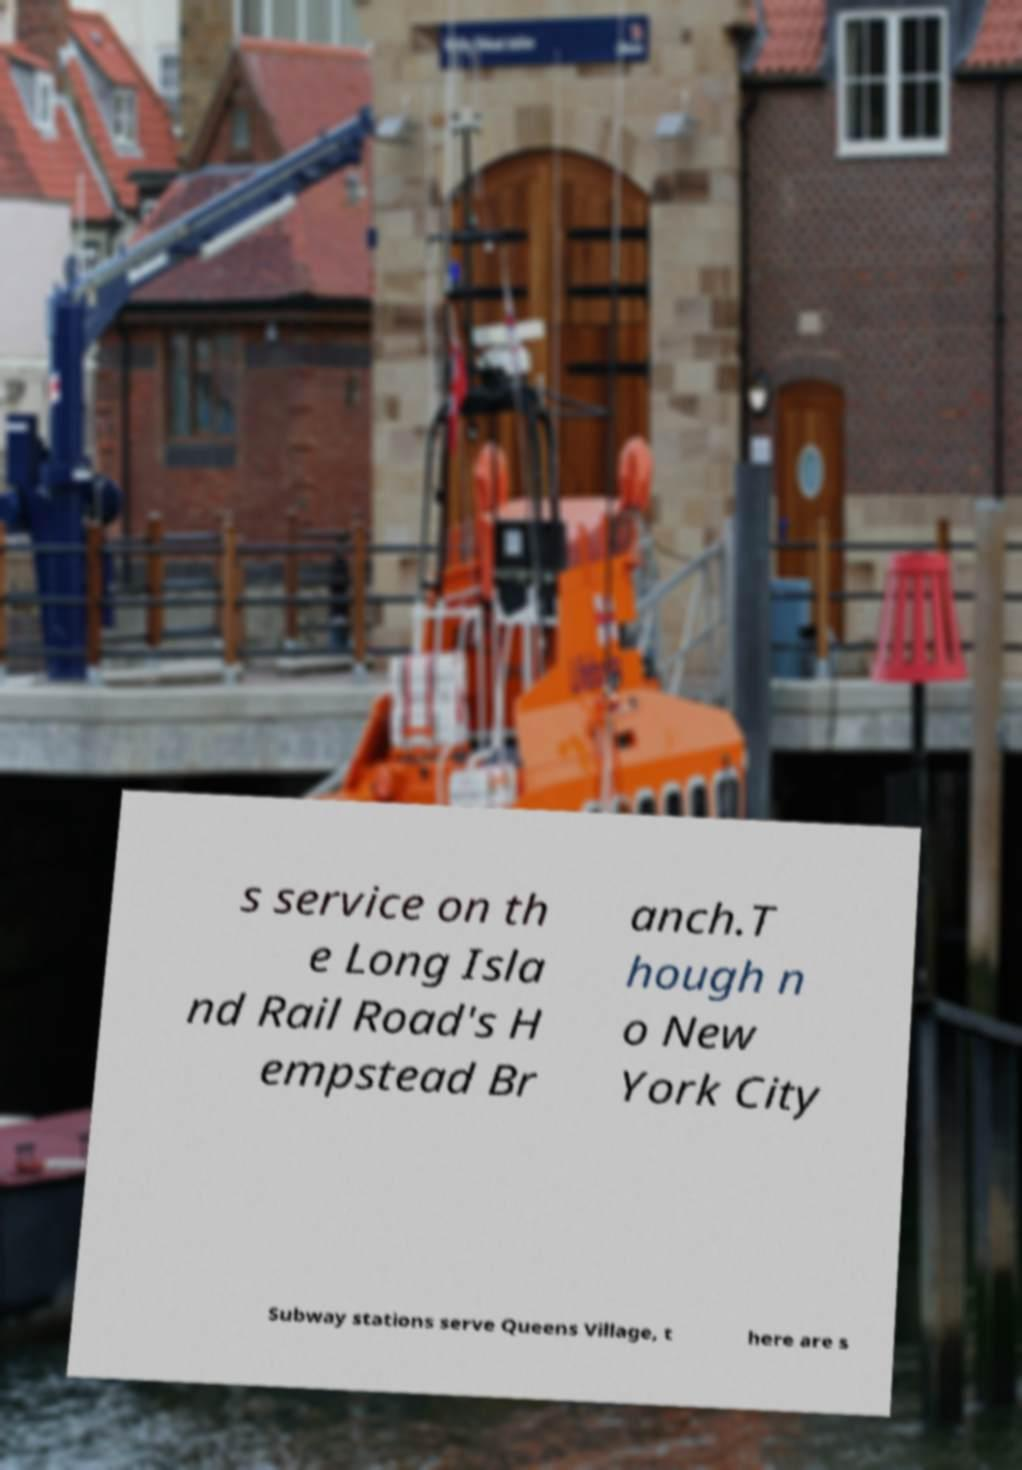Can you accurately transcribe the text from the provided image for me? s service on th e Long Isla nd Rail Road's H empstead Br anch.T hough n o New York City Subway stations serve Queens Village, t here are s 